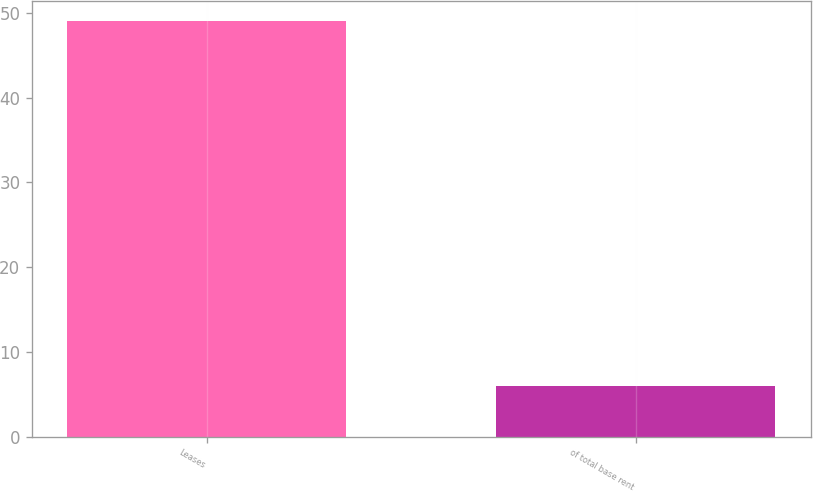Convert chart to OTSL. <chart><loc_0><loc_0><loc_500><loc_500><bar_chart><fcel>Leases<fcel>of total base rent<nl><fcel>49<fcel>6<nl></chart> 